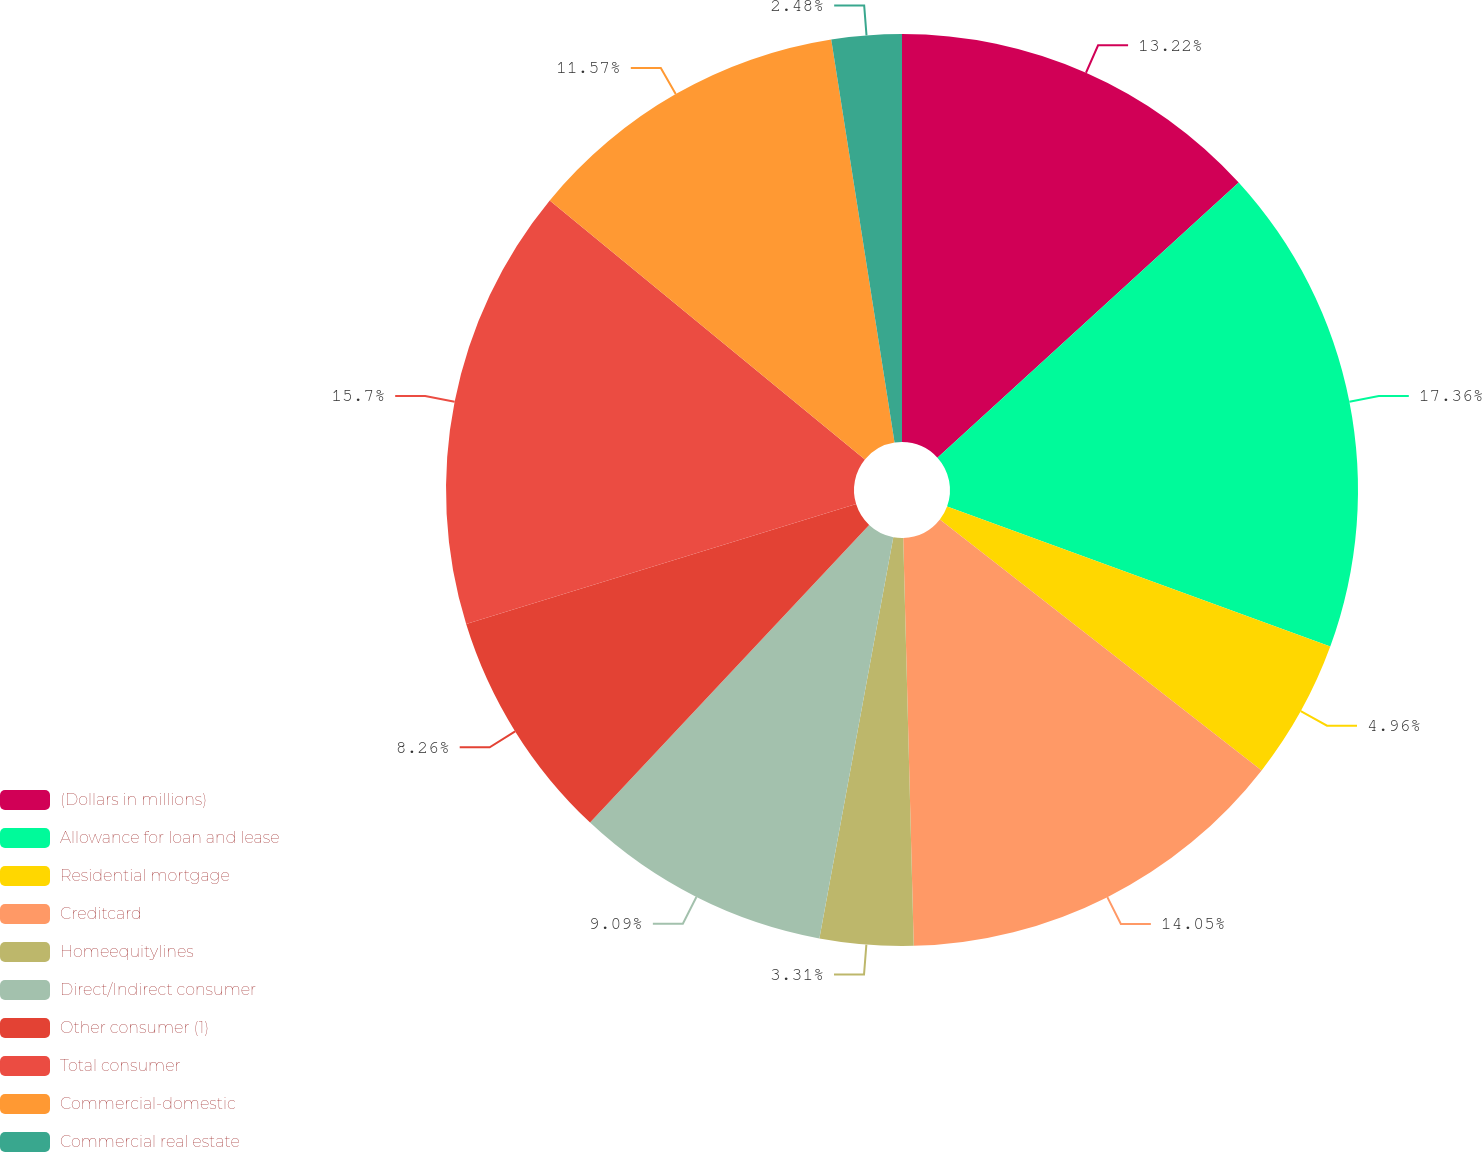Convert chart to OTSL. <chart><loc_0><loc_0><loc_500><loc_500><pie_chart><fcel>(Dollars in millions)<fcel>Allowance for loan and lease<fcel>Residential mortgage<fcel>Creditcard<fcel>Homeequitylines<fcel>Direct/Indirect consumer<fcel>Other consumer (1)<fcel>Total consumer<fcel>Commercial-domestic<fcel>Commercial real estate<nl><fcel>13.22%<fcel>17.36%<fcel>4.96%<fcel>14.05%<fcel>3.31%<fcel>9.09%<fcel>8.26%<fcel>15.7%<fcel>11.57%<fcel>2.48%<nl></chart> 